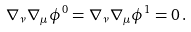Convert formula to latex. <formula><loc_0><loc_0><loc_500><loc_500>\nabla _ { \nu } \nabla _ { \mu } \phi ^ { 0 } = \nabla _ { \nu } \nabla _ { \mu } \phi ^ { 1 } = 0 \, .</formula> 